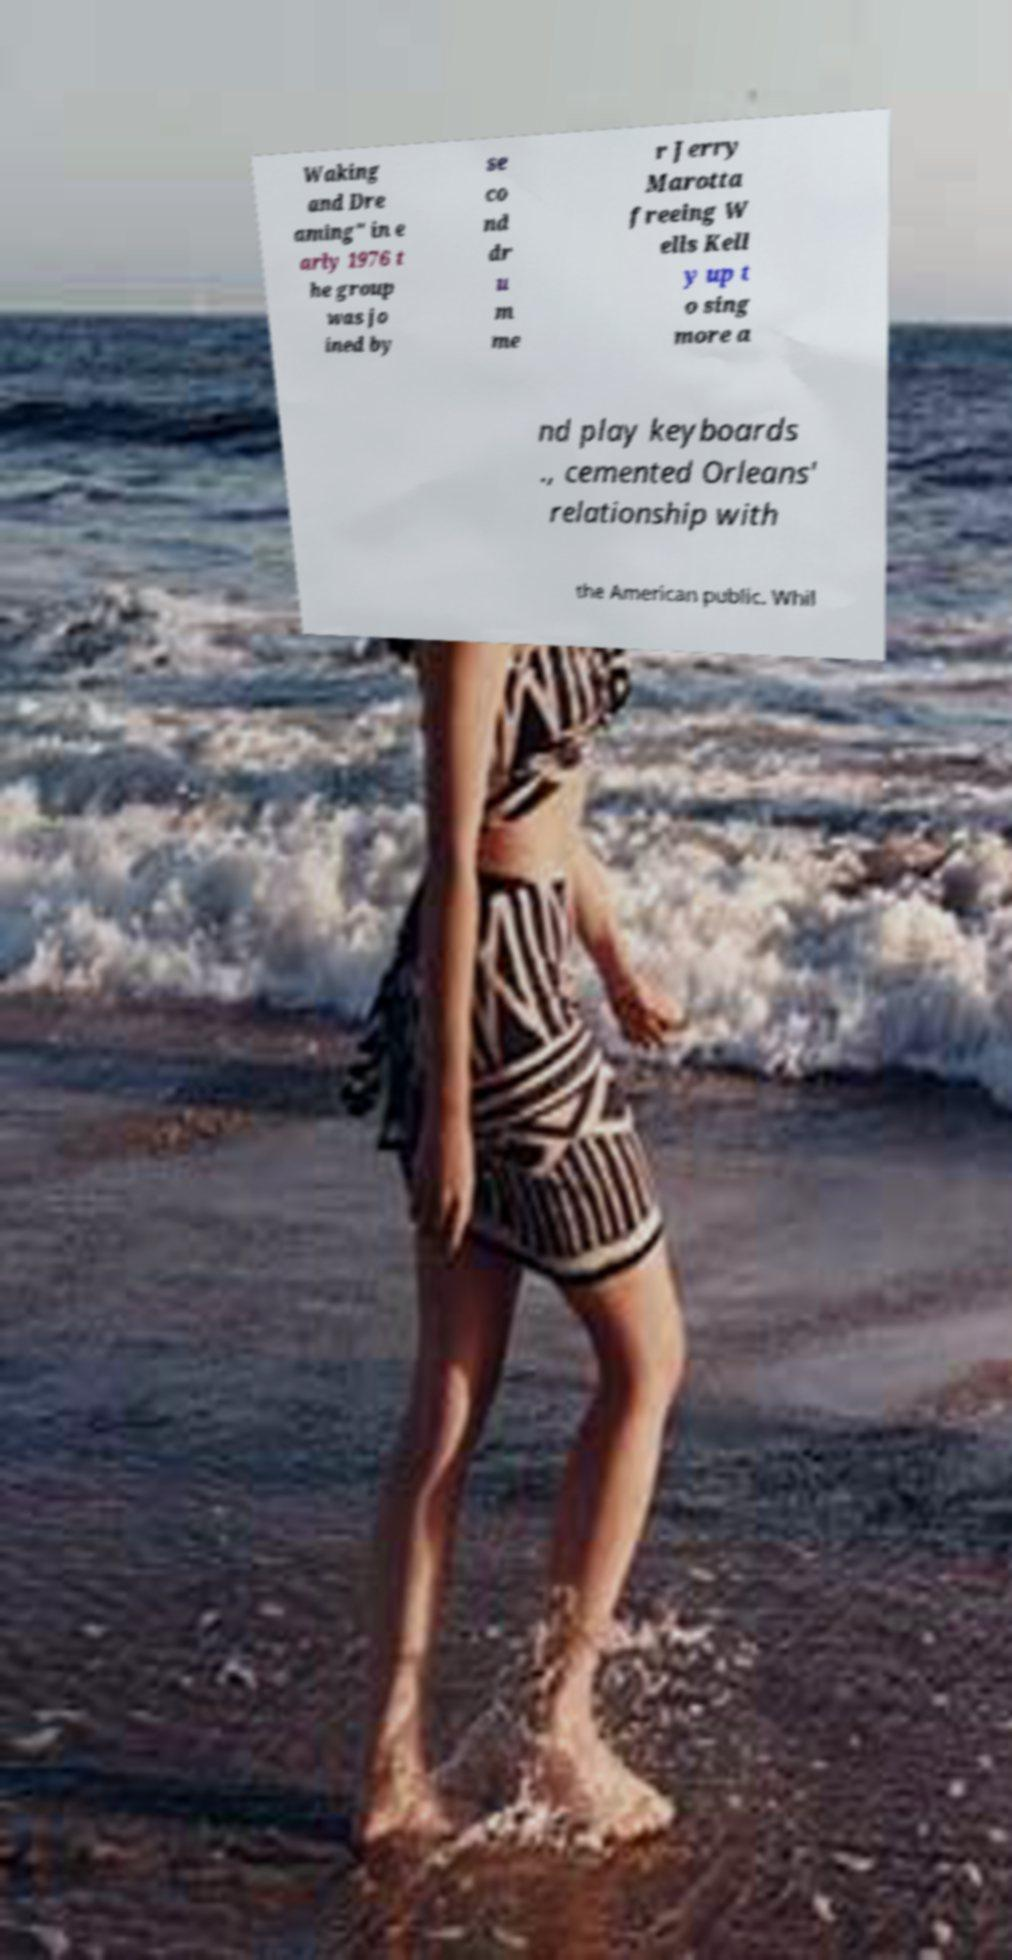I need the written content from this picture converted into text. Can you do that? Waking and Dre aming" in e arly 1976 t he group was jo ined by se co nd dr u m me r Jerry Marotta freeing W ells Kell y up t o sing more a nd play keyboards ., cemented Orleans' relationship with the American public. Whil 